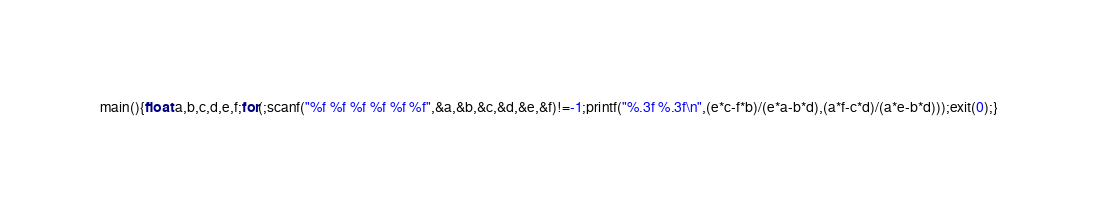Convert code to text. <code><loc_0><loc_0><loc_500><loc_500><_C_>main(){float a,b,c,d,e,f;for(;scanf("%f %f %f %f %f %f",&a,&b,&c,&d,&e,&f)!=-1;printf("%.3f %.3f\n",(e*c-f*b)/(e*a-b*d),(a*f-c*d)/(a*e-b*d)));exit(0);}</code> 